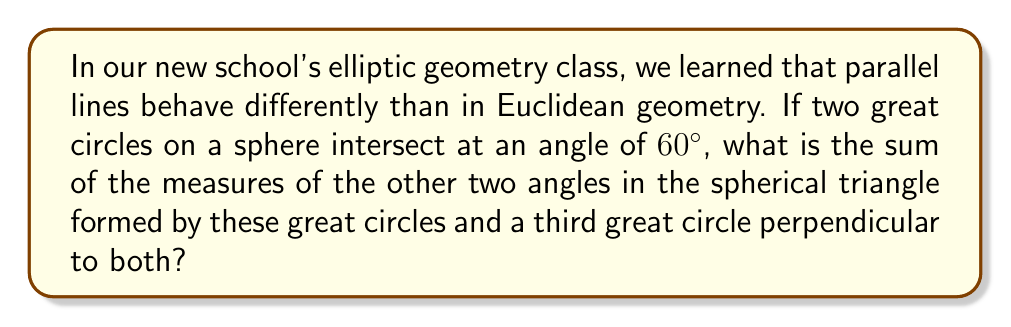Give your solution to this math problem. Let's approach this step-by-step:

1) In elliptic geometry, specifically on a sphere, great circles play the role of "straight lines."

2) In spherical geometry, there are no parallel lines as all great circles intersect.

3) The sum of angles in a spherical triangle is always greater than $180^\circ$. The excess over $180^\circ$ is proportional to the area of the triangle.

4) For a right-angled spherical triangle (one with a $90^\circ$ angle), we can use the formula:

   $$\cos A = \tan b \cot c$$

   where $A$ is the angle opposite the side $a$, and $b$ and $c$ are the other two sides.

5) In our case, we have a right angle and a $60^\circ$ angle. Let's call the unknown angle $x$. So we have:

   $$60^\circ + 90^\circ + x = 180^\circ + \text{excess}$$

6) In a right-angled spherical triangle with one angle $60^\circ$, the third angle must be greater than $30^\circ$ (which would make $180^\circ$ in total).

7) Using the spherical Pythagorean theorem:

   $$\cos 90^\circ = \cos 60^\circ \cos x + \sin 60^\circ \sin x \cos 90^\circ$$

8) Simplifying:

   $$0 = \frac{1}{2} \cos x + 0$$

   $$\cos x = 0$$

9) Therefore, $x = 90^\circ$

10) The sum of all angles is thus: $60^\circ + 90^\circ + 90^\circ = 240^\circ$

11) The sum of the other two angles (excluding the given $60^\circ$) is $90^\circ + 90^\circ = 180^\circ$
Answer: $180^\circ$ 